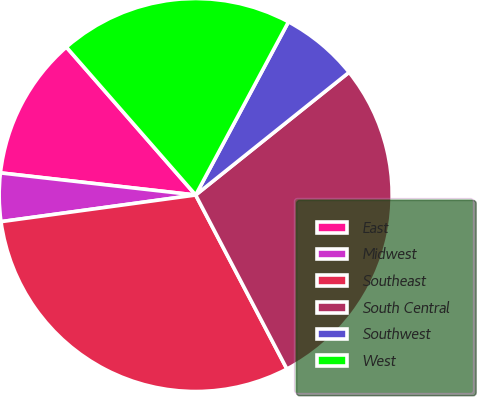Convert chart. <chart><loc_0><loc_0><loc_500><loc_500><pie_chart><fcel>East<fcel>Midwest<fcel>Southeast<fcel>South Central<fcel>Southwest<fcel>West<nl><fcel>11.77%<fcel>3.96%<fcel>30.52%<fcel>28.05%<fcel>6.43%<fcel>19.26%<nl></chart> 